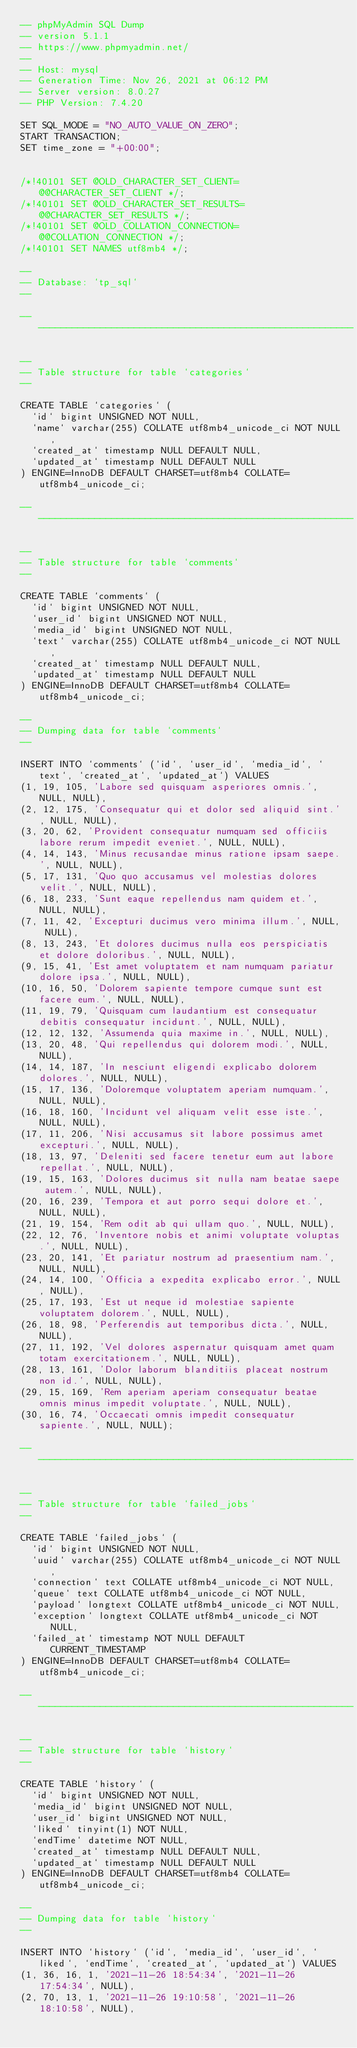Convert code to text. <code><loc_0><loc_0><loc_500><loc_500><_SQL_>-- phpMyAdmin SQL Dump
-- version 5.1.1
-- https://www.phpmyadmin.net/
--
-- Host: mysql
-- Generation Time: Nov 26, 2021 at 06:12 PM
-- Server version: 8.0.27
-- PHP Version: 7.4.20

SET SQL_MODE = "NO_AUTO_VALUE_ON_ZERO";
START TRANSACTION;
SET time_zone = "+00:00";


/*!40101 SET @OLD_CHARACTER_SET_CLIENT=@@CHARACTER_SET_CLIENT */;
/*!40101 SET @OLD_CHARACTER_SET_RESULTS=@@CHARACTER_SET_RESULTS */;
/*!40101 SET @OLD_COLLATION_CONNECTION=@@COLLATION_CONNECTION */;
/*!40101 SET NAMES utf8mb4 */;

--
-- Database: `tp_sql`
--

-- --------------------------------------------------------

--
-- Table structure for table `categories`
--

CREATE TABLE `categories` (
  `id` bigint UNSIGNED NOT NULL,
  `name` varchar(255) COLLATE utf8mb4_unicode_ci NOT NULL,
  `created_at` timestamp NULL DEFAULT NULL,
  `updated_at` timestamp NULL DEFAULT NULL
) ENGINE=InnoDB DEFAULT CHARSET=utf8mb4 COLLATE=utf8mb4_unicode_ci;

-- --------------------------------------------------------

--
-- Table structure for table `comments`
--

CREATE TABLE `comments` (
  `id` bigint UNSIGNED NOT NULL,
  `user_id` bigint UNSIGNED NOT NULL,
  `media_id` bigint UNSIGNED NOT NULL,
  `text` varchar(255) COLLATE utf8mb4_unicode_ci NOT NULL,
  `created_at` timestamp NULL DEFAULT NULL,
  `updated_at` timestamp NULL DEFAULT NULL
) ENGINE=InnoDB DEFAULT CHARSET=utf8mb4 COLLATE=utf8mb4_unicode_ci;

--
-- Dumping data for table `comments`
--

INSERT INTO `comments` (`id`, `user_id`, `media_id`, `text`, `created_at`, `updated_at`) VALUES
(1, 19, 105, 'Labore sed quisquam asperiores omnis.', NULL, NULL),
(2, 12, 175, 'Consequatur qui et dolor sed aliquid sint.', NULL, NULL),
(3, 20, 62, 'Provident consequatur numquam sed officiis labore rerum impedit eveniet.', NULL, NULL),
(4, 14, 143, 'Minus recusandae minus ratione ipsam saepe.', NULL, NULL),
(5, 17, 131, 'Quo quo accusamus vel molestias dolores velit.', NULL, NULL),
(6, 18, 233, 'Sunt eaque repellendus nam quidem et.', NULL, NULL),
(7, 11, 42, 'Excepturi ducimus vero minima illum.', NULL, NULL),
(8, 13, 243, 'Et dolores ducimus nulla eos perspiciatis et dolore doloribus.', NULL, NULL),
(9, 15, 41, 'Est amet voluptatem et nam numquam pariatur dolore ipsa.', NULL, NULL),
(10, 16, 50, 'Dolorem sapiente tempore cumque sunt est facere eum.', NULL, NULL),
(11, 19, 79, 'Quisquam cum laudantium est consequatur debitis consequatur incidunt.', NULL, NULL),
(12, 12, 132, 'Assumenda quia maxime in.', NULL, NULL),
(13, 20, 48, 'Qui repellendus qui dolorem modi.', NULL, NULL),
(14, 14, 187, 'In nesciunt eligendi explicabo dolorem dolores.', NULL, NULL),
(15, 17, 136, 'Doloremque voluptatem aperiam numquam.', NULL, NULL),
(16, 18, 160, 'Incidunt vel aliquam velit esse iste.', NULL, NULL),
(17, 11, 206, 'Nisi accusamus sit labore possimus amet excepturi.', NULL, NULL),
(18, 13, 97, 'Deleniti sed facere tenetur eum aut labore repellat.', NULL, NULL),
(19, 15, 163, 'Dolores ducimus sit nulla nam beatae saepe autem.', NULL, NULL),
(20, 16, 239, 'Tempora et aut porro sequi dolore et.', NULL, NULL),
(21, 19, 154, 'Rem odit ab qui ullam quo.', NULL, NULL),
(22, 12, 76, 'Inventore nobis et animi voluptate voluptas.', NULL, NULL),
(23, 20, 141, 'Et pariatur nostrum ad praesentium nam.', NULL, NULL),
(24, 14, 100, 'Officia a expedita explicabo error.', NULL, NULL),
(25, 17, 193, 'Est ut neque id molestiae sapiente voluptatem dolorem.', NULL, NULL),
(26, 18, 98, 'Perferendis aut temporibus dicta.', NULL, NULL),
(27, 11, 192, 'Vel dolores aspernatur quisquam amet quam totam exercitationem.', NULL, NULL),
(28, 13, 161, 'Dolor laborum blanditiis placeat nostrum non id.', NULL, NULL),
(29, 15, 169, 'Rem aperiam aperiam consequatur beatae omnis minus impedit voluptate.', NULL, NULL),
(30, 16, 74, 'Occaecati omnis impedit consequatur sapiente.', NULL, NULL);

-- --------------------------------------------------------

--
-- Table structure for table `failed_jobs`
--

CREATE TABLE `failed_jobs` (
  `id` bigint UNSIGNED NOT NULL,
  `uuid` varchar(255) COLLATE utf8mb4_unicode_ci NOT NULL,
  `connection` text COLLATE utf8mb4_unicode_ci NOT NULL,
  `queue` text COLLATE utf8mb4_unicode_ci NOT NULL,
  `payload` longtext COLLATE utf8mb4_unicode_ci NOT NULL,
  `exception` longtext COLLATE utf8mb4_unicode_ci NOT NULL,
  `failed_at` timestamp NOT NULL DEFAULT CURRENT_TIMESTAMP
) ENGINE=InnoDB DEFAULT CHARSET=utf8mb4 COLLATE=utf8mb4_unicode_ci;

-- --------------------------------------------------------

--
-- Table structure for table `history`
--

CREATE TABLE `history` (
  `id` bigint UNSIGNED NOT NULL,
  `media_id` bigint UNSIGNED NOT NULL,
  `user_id` bigint UNSIGNED NOT NULL,
  `liked` tinyint(1) NOT NULL,
  `endTime` datetime NOT NULL,
  `created_at` timestamp NULL DEFAULT NULL,
  `updated_at` timestamp NULL DEFAULT NULL
) ENGINE=InnoDB DEFAULT CHARSET=utf8mb4 COLLATE=utf8mb4_unicode_ci;

--
-- Dumping data for table `history`
--

INSERT INTO `history` (`id`, `media_id`, `user_id`, `liked`, `endTime`, `created_at`, `updated_at`) VALUES
(1, 36, 16, 1, '2021-11-26 18:54:34', '2021-11-26 17:54:34', NULL),
(2, 70, 13, 1, '2021-11-26 19:10:58', '2021-11-26 18:10:58', NULL),</code> 